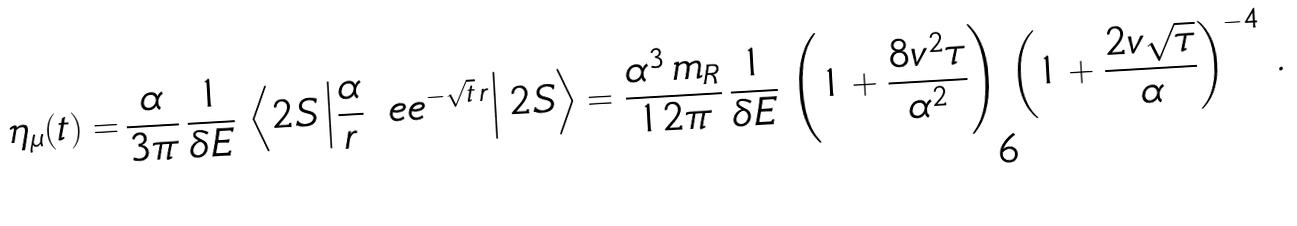<formula> <loc_0><loc_0><loc_500><loc_500>\eta _ { \mu } ( t ) = & \, \frac { \alpha } { 3 \pi } \, \frac { 1 } { \delta E } \, \left < 2 S \left | \frac { \alpha } { r } \, \ e e ^ { - \sqrt { t } \, r } \right | 2 S \right > = \frac { \alpha ^ { 3 } \, m _ { R } } { 1 2 \pi } \, \frac { 1 } { \delta E } \, \left ( 1 + \frac { 8 v ^ { 2 } \tau } { \alpha ^ { 2 } } \right ) \, \left ( 1 + \frac { 2 v \sqrt { \tau } } { \alpha } \right ) ^ { - 4 } \, .</formula> 